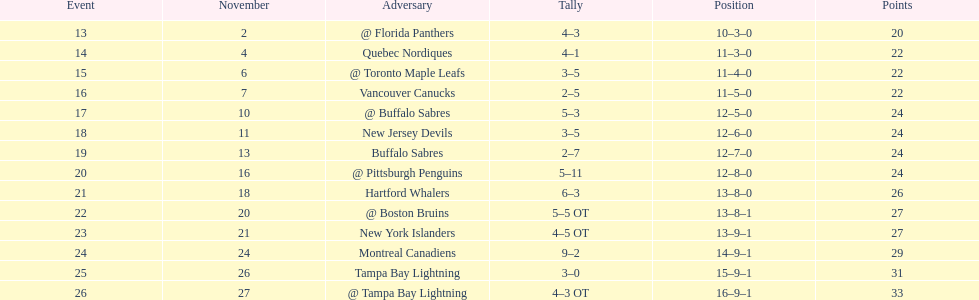Which teams scored 35 points or more in total? Hartford Whalers, @ Boston Bruins, New York Islanders, Montreal Canadiens, Tampa Bay Lightning, @ Tampa Bay Lightning. Of those teams, which team was the only one to score 3-0? Tampa Bay Lightning. 